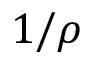Convert formula to latex. <formula><loc_0><loc_0><loc_500><loc_500>1 / \rho</formula> 